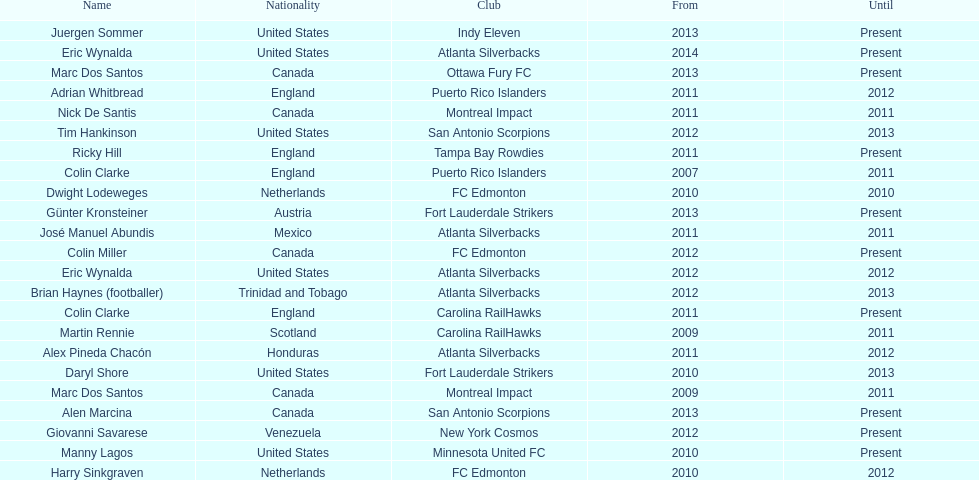Who was the coach of fc edmonton before miller? Harry Sinkgraven. 